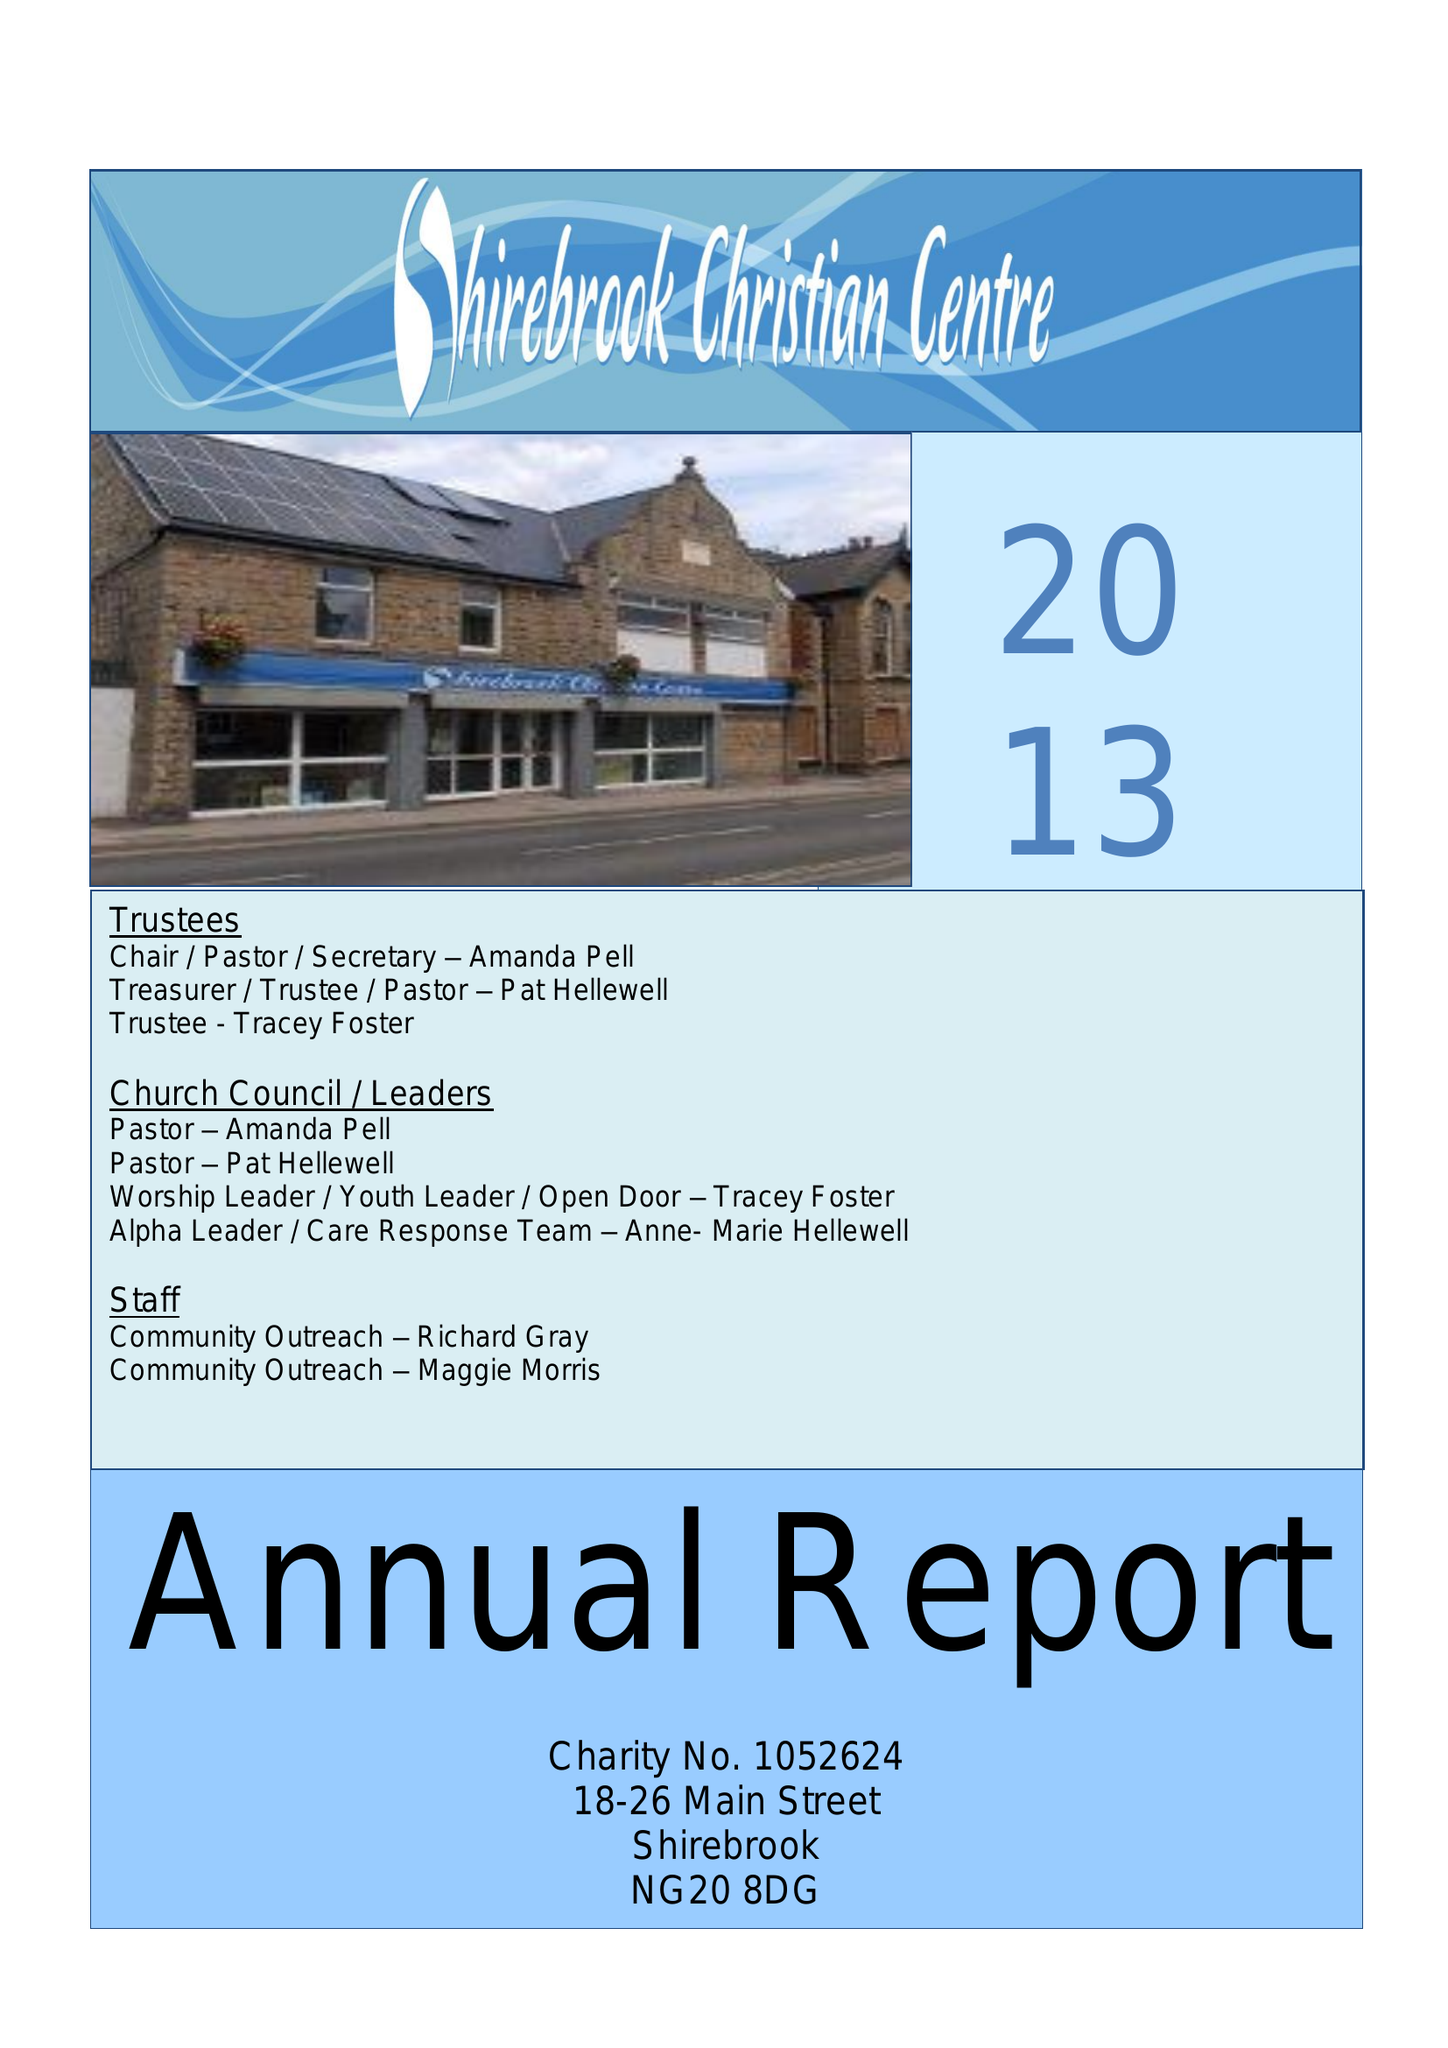What is the value for the charity_name?
Answer the question using a single word or phrase. The Brook Community Church and Centre 